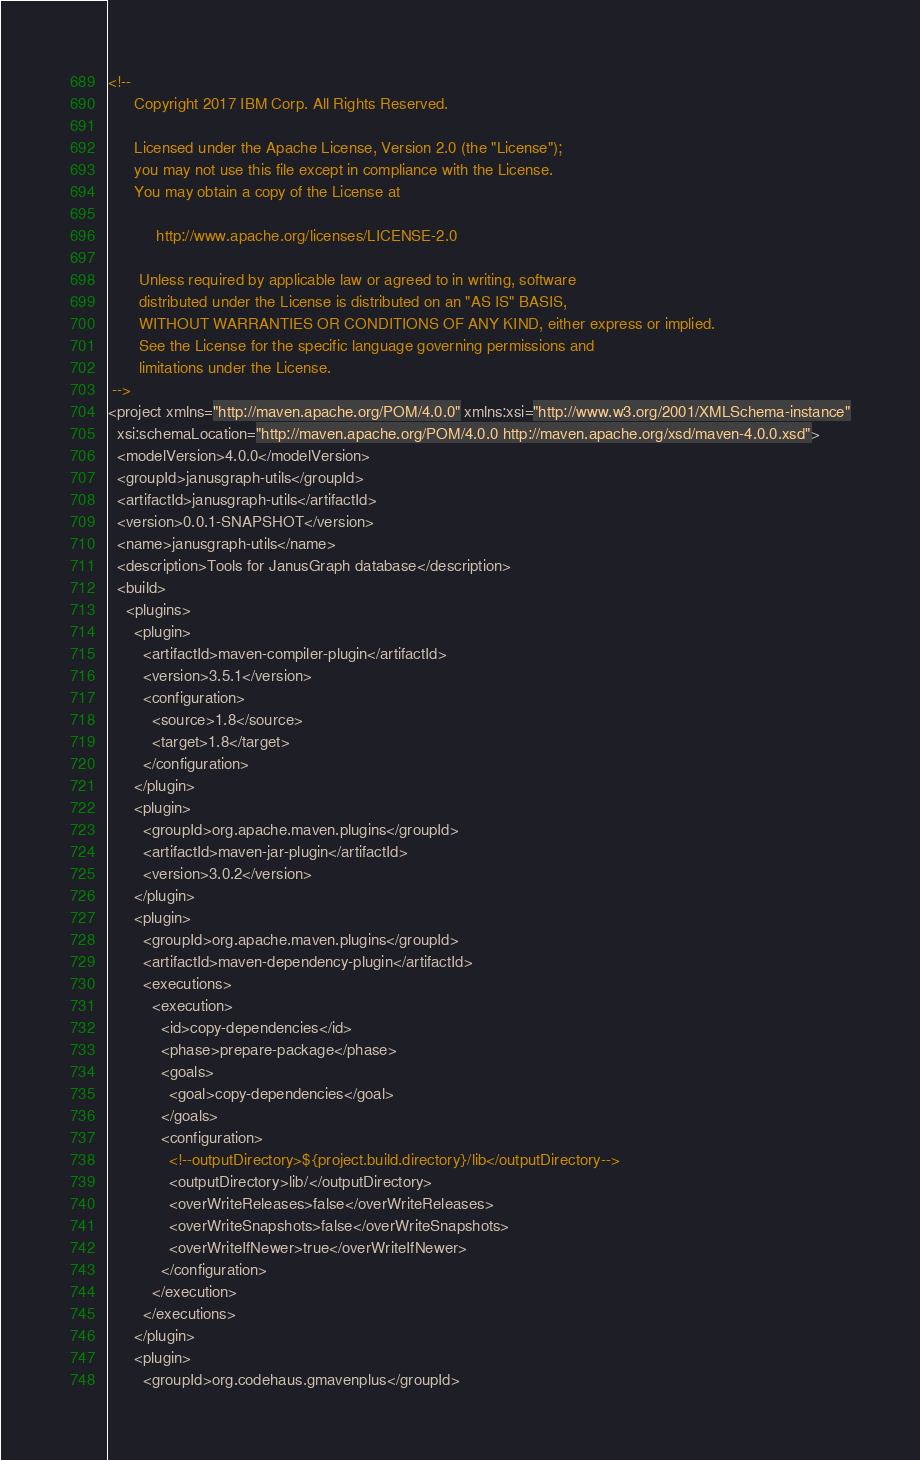Convert code to text. <code><loc_0><loc_0><loc_500><loc_500><_XML_><!--
      Copyright 2017 IBM Corp. All Rights Reserved.

      Licensed under the Apache License, Version 2.0 (the "License");
      you may not use this file except in compliance with the License.
      You may obtain a copy of the License at

           http://www.apache.org/licenses/LICENSE-2.0

       Unless required by applicable law or agreed to in writing, software
       distributed under the License is distributed on an "AS IS" BASIS,
       WITHOUT WARRANTIES OR CONDITIONS OF ANY KIND, either express or implied.
       See the License for the specific language governing permissions and
       limitations under the License.
 -->
<project xmlns="http://maven.apache.org/POM/4.0.0" xmlns:xsi="http://www.w3.org/2001/XMLSchema-instance"
  xsi:schemaLocation="http://maven.apache.org/POM/4.0.0 http://maven.apache.org/xsd/maven-4.0.0.xsd">
  <modelVersion>4.0.0</modelVersion>
  <groupId>janusgraph-utils</groupId>
  <artifactId>janusgraph-utils</artifactId>
  <version>0.0.1-SNAPSHOT</version>
  <name>janusgraph-utils</name>
  <description>Tools for JanusGraph database</description>
  <build>
    <plugins>
      <plugin>
        <artifactId>maven-compiler-plugin</artifactId>
        <version>3.5.1</version>
        <configuration>
          <source>1.8</source>
          <target>1.8</target>
        </configuration>
      </plugin>
      <plugin>
        <groupId>org.apache.maven.plugins</groupId>
        <artifactId>maven-jar-plugin</artifactId>
        <version>3.0.2</version>
      </plugin>
      <plugin>
        <groupId>org.apache.maven.plugins</groupId>
        <artifactId>maven-dependency-plugin</artifactId>
        <executions>
          <execution>
            <id>copy-dependencies</id>
            <phase>prepare-package</phase>
            <goals>
              <goal>copy-dependencies</goal>
            </goals>
            <configuration>
              <!--outputDirectory>${project.build.directory}/lib</outputDirectory-->
              <outputDirectory>lib/</outputDirectory>
              <overWriteReleases>false</overWriteReleases>
              <overWriteSnapshots>false</overWriteSnapshots>
              <overWriteIfNewer>true</overWriteIfNewer>
            </configuration>
          </execution>
        </executions>
      </plugin>
      <plugin>
        <groupId>org.codehaus.gmavenplus</groupId></code> 